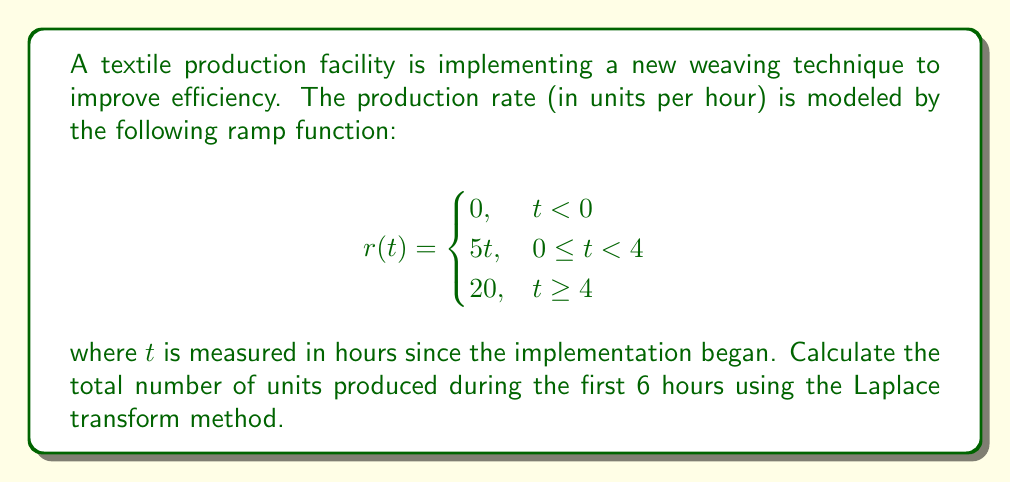What is the answer to this math problem? To solve this problem, we'll use the following steps:

1) First, we need to find the Laplace transform of the given ramp function.

2) The Laplace transform of a ramp function is given by:

   $$\mathcal{L}\{r(t)\} = \frac{a}{s^2} + \frac{b-a}{s^2}e^{-cs}$$

   where $a$ is the slope of the ramp, $b$ is the final value, and $c$ is the time when the ramp reaches its final value.

3) In our case, $a=5$, $b=20$, and $c=4$. So, the Laplace transform of our function is:

   $$R(s) = \frac{5}{s^2} + \frac{20-5}{s^2}e^{-4s} = \frac{5}{s^2} + \frac{15}{s^2}e^{-4s}$$

4) To find the total production, we need to integrate this function from 0 to 6. In the Laplace domain, integration corresponds to division by $s$. So, we have:

   $$\frac{R(s)}{s} = \frac{5}{s^3} + \frac{15}{s^3}e^{-4s}$$

5) Now, we need to find the inverse Laplace transform of this function and evaluate it at $t=6$. The inverse transform is:

   $$\mathcal{L}^{-1}\{\frac{5}{s^3}\} = \frac{5t^2}{2}$$
   $$\mathcal{L}^{-1}\{\frac{15}{s^3}e^{-4s}\} = \frac{15}{2}(t-4)^2u(t-4)$$

   where $u(t)$ is the unit step function.

6) Combining these and evaluating at $t=6$:

   $$\text{Total Production} = \frac{5(6^2)}{2} + \frac{15}{2}(6-4)^2 = 90 + 30 = 120$$

Therefore, the total number of units produced during the first 6 hours is 120.
Answer: 120 units 